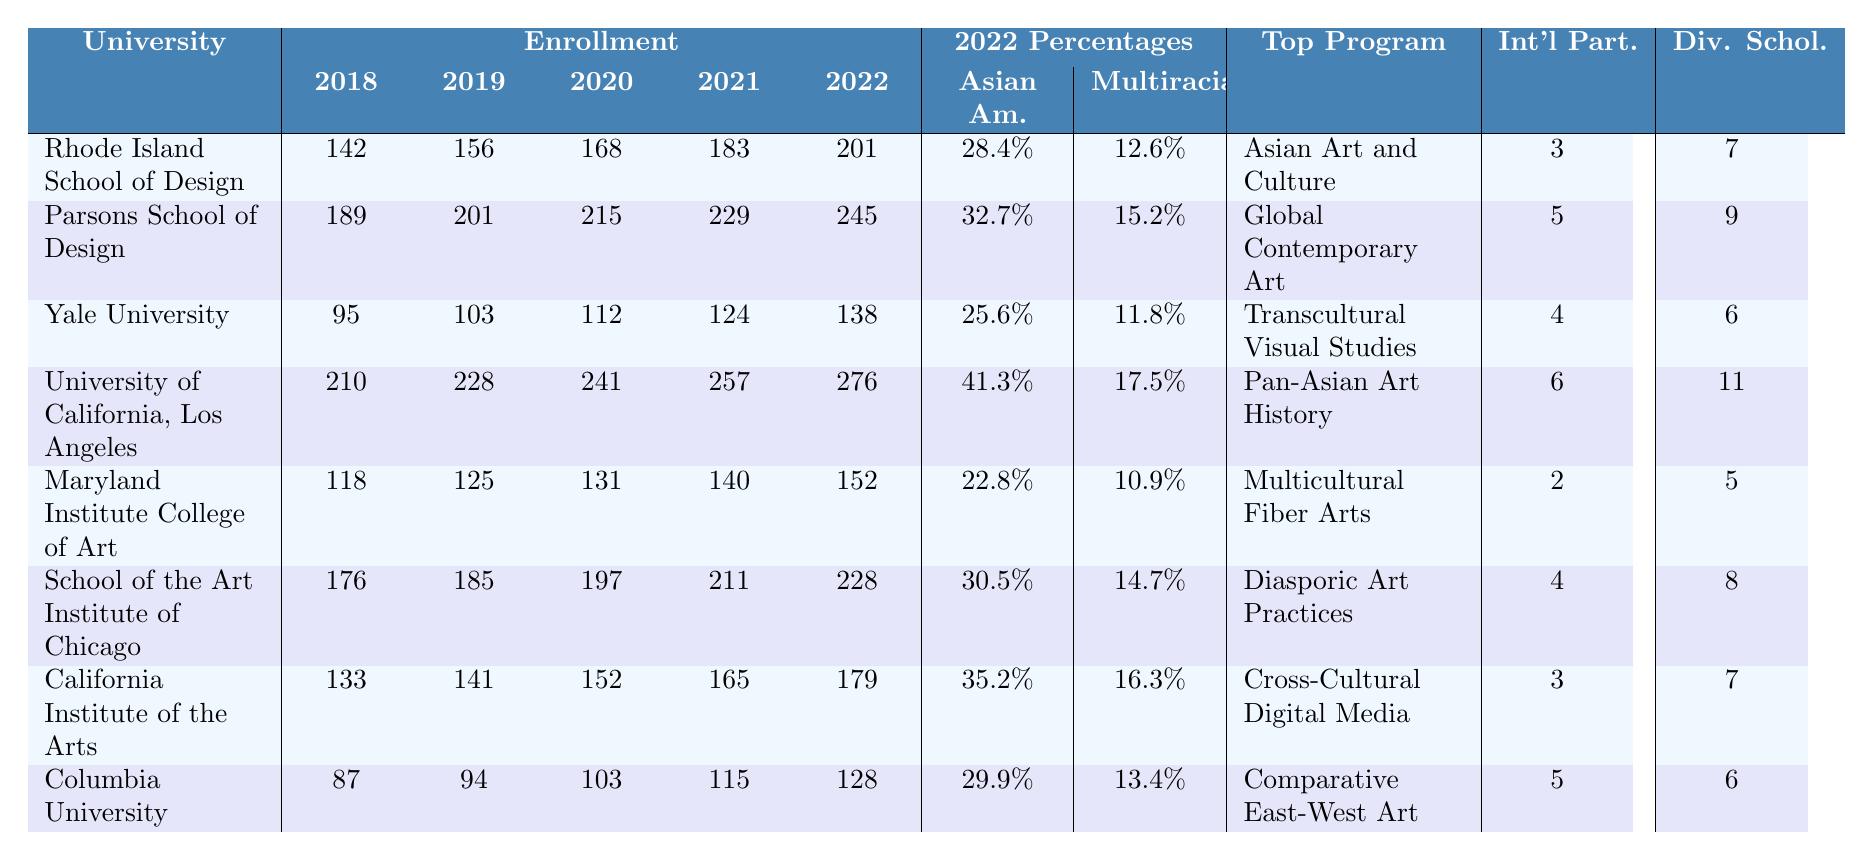What was the enrollment of the University of California, Los Angeles in 2021? From the table, the 2021 enrollment for the University of California, Los Angeles is listed under the 2021 column next to its name. The value is 257.
Answer: 257 Which university had the highest enrollment in 2022? Looking at the 2022 enrollment column, the highest value is 276, which corresponds to the University of California, Los Angeles.
Answer: University of California, Los Angeles What is the Asian American percentage of students at the California Institute of the Arts in 2022? The table shows that for the California Institute of the Arts, the Asian American percentage in 2022 is listed as 35.2%.
Answer: 35.2% What is the difference in enrollment between the lowest (Columbia University) and the highest (University of California, Los Angeles) for 2022? Columbia University's enrollment for 2022 is 128, and the University of California, Los Angeles has 276. The difference is calculated as 276 - 128 = 148.
Answer: 148 What are the total diversity scholarships offered across all universities for 2022? To find the total diversity scholarships, sum the values from the 2022 column: 7 + 9 + 6 + 11 + 5 + 8 + 7 + 6 = 59.
Answer: 59 Is the percentage of multiracial students at Parsons School of Design higher than 15% in 2022? The table shows the multiracial percentage for Parsons School of Design in 2022 is 15.2%. Since 15.2% is greater than 15%, the answer is yes.
Answer: Yes Which university has the most international partnerships, and how many are there? Referring to the international partnerships column, the university with the most partnerships is the University of California, Los Angeles with 6 partnerships.
Answer: University of California, Los Angeles, 6 Calculate the average enrollment of all universities for the year 2019. The total enrollment for 2019 is 201 + 201 + 103 + 228 + 125 + 185 + 141 + 94 = 1,446. There are 8 universities, so the average is 1,446 / 8 = 180.75.
Answer: 180.75 How many universities offer more than 6 diversity scholarships in 2022? From the table, the universities that offer more than 6 diversity scholarships are Parsons School of Design (9), University of California, Los Angeles (11), and School of the Art Institute of Chicago (8). This gives a total of 3 universities.
Answer: 3 Which program at the Maryland Institute College of Art is listed as the top multicultural art program? The table states that the top multicultural art program at the Maryland Institute College of Art is Multicultural Fiber Arts.
Answer: Multicultural Fiber Arts What percentage of students at Yale University are classified as multiracial in 2022? Directly from the table, Yale University's multiracial percentage for 2022 is 11.8%.
Answer: 11.8% 